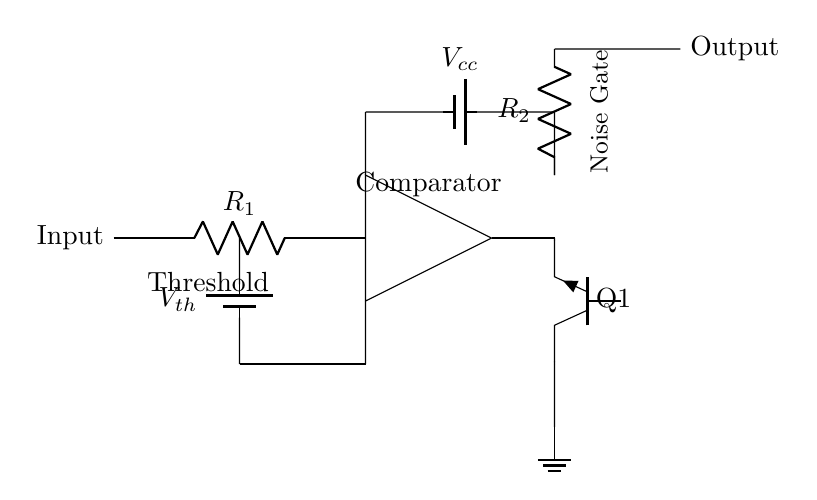What is the purpose of the comparator in this circuit? The comparator's role is to compare the input signal level against the threshold voltage. When the input exceeds the threshold, it activates the transistor to allow only the desired signal through.
Answer: To compare input levels What type of transistor is used in this circuit? The schematic indicates the use of a npn transistor, as denoted by the label on the transistor symbol. This type of transistor allows current to flow when a sufficient voltage is applied to its base.
Answer: NPN What does Vcc represent in the circuit? Vcc is typically the positive supply voltage for the circuit, providing the necessary power for the active components, including the comparator and the transistor.
Answer: Positive supply voltage What is the connection between the comparator and the transistor? The output of the comparator directly controls the base of the transistor. When the comparator output indicates that the input signal is above the threshold, it turns on the transistor, allowing it to pass the signal.
Answer: Comparator output to transistor base What is the threshold voltage in this circuit? The threshold voltage is represented by the battery labeled Vth and serves as the reference level that determines when the transistor will be activated based on the input signal.
Answer: Vth How does this circuit reduce background noise in recordings? The circuit reduces background noise by silencing the output when the input signal is below the threshold voltage. When the input signal is higher than the threshold, only those signals are allowed through to the output, effectively gating the noise.
Answer: It gates the noise 